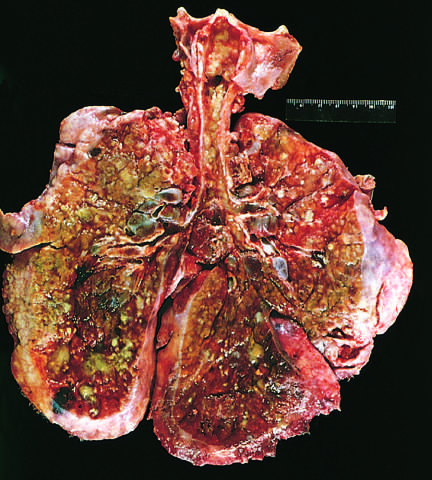what are apparent?
Answer the question using a single word or phrase. Extensive mucous plugging and dilation of the tracheobronchial tree 